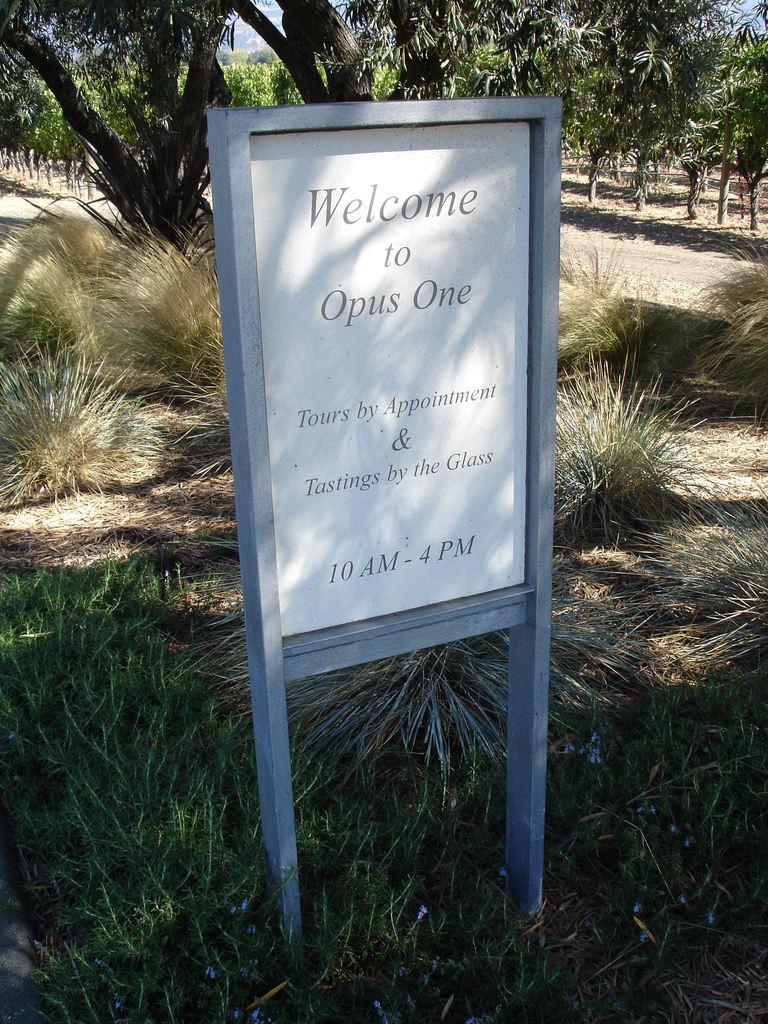Please provide a concise description of this image. This image is taken outdoors. At the bottom of the image there is a ground with grass on it. In the background there are many trees and plants. In the middle of the image there is a board with a text on it. 